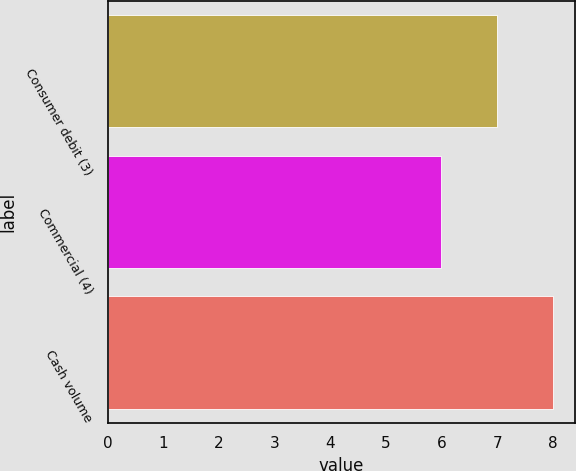Convert chart to OTSL. <chart><loc_0><loc_0><loc_500><loc_500><bar_chart><fcel>Consumer debit (3)<fcel>Commercial (4)<fcel>Cash volume<nl><fcel>7<fcel>6<fcel>8<nl></chart> 